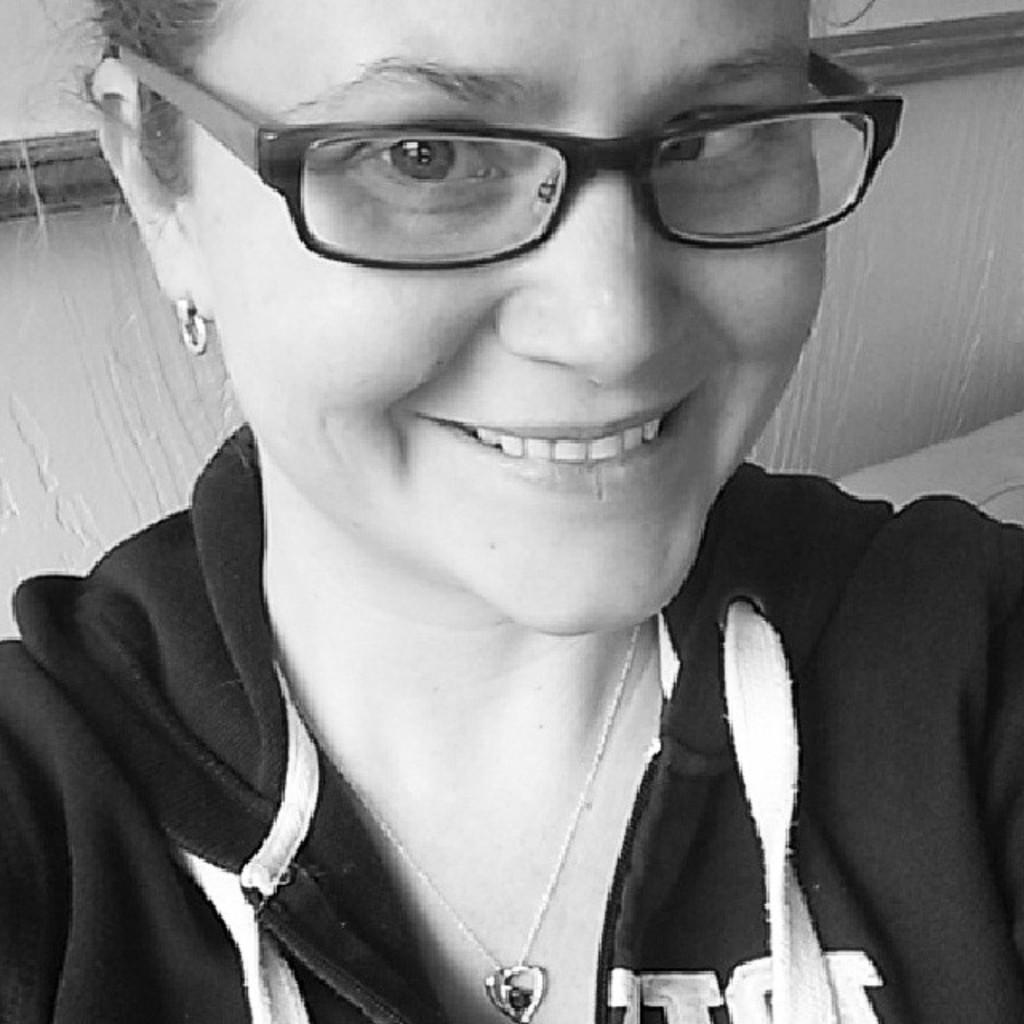Who is present in the image? There is a woman in the image. What is the woman wearing? The woman is wearing a black jacket. What can be seen in the background of the image? There is a wall in the background of the image. How does the woman's wealth contribute to the quietness of the tramp in the image? There is no tramp or mention of wealth in the image; it only features a woman wearing a black jacket with a wall in the background. 